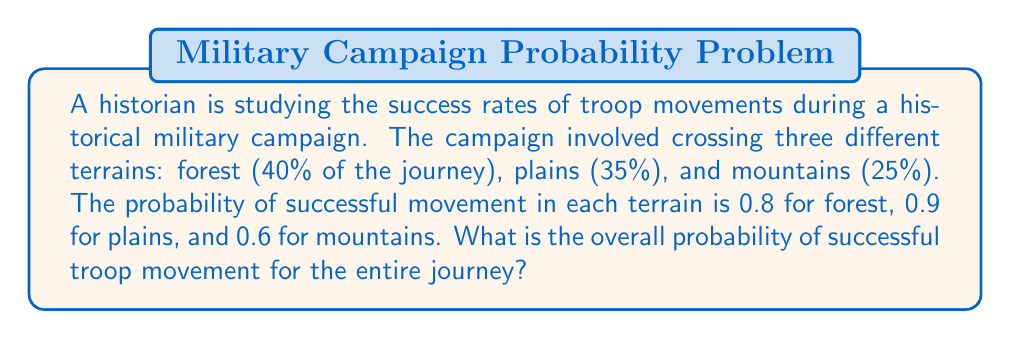Give your solution to this math problem. To solve this problem, we need to follow these steps:

1. Identify the probability of success for each terrain:
   - Forest: $P(F) = 0.8$
   - Plains: $P(P) = 0.9$
   - Mountains: $P(M) = 0.6$

2. Determine the proportion of each terrain in the journey:
   - Forest: 40% or 0.4
   - Plains: 35% or 0.35
   - Mountains: 25% or 0.25

3. Calculate the weighted probability for each terrain:
   - Forest: $0.4 \times 0.8 = 0.32$
   - Plains: $0.35 \times 0.9 = 0.315$
   - Mountains: $0.25 \times 0.6 = 0.15$

4. Sum the weighted probabilities to get the overall probability:

   $$P(\text{success}) = (0.4 \times 0.8) + (0.35 \times 0.9) + (0.25 \times 0.6)$$
   $$P(\text{success}) = 0.32 + 0.315 + 0.15$$
   $$P(\text{success}) = 0.785$$

Therefore, the overall probability of successful troop movement for the entire journey is 0.785 or 78.5%.
Answer: 0.785 